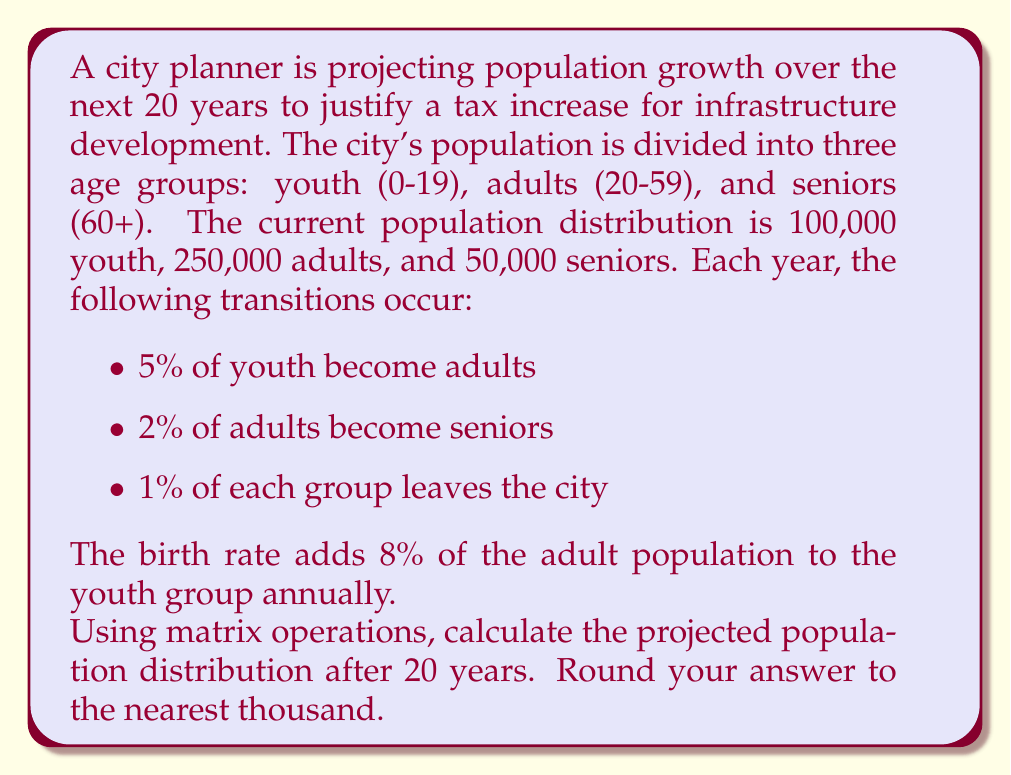Can you solve this math problem? Let's approach this step-by-step using matrix operations:

1) First, we'll set up our initial population vector:

   $$\vec{p}_0 = \begin{bmatrix} 100000 \\ 250000 \\ 50000 \end{bmatrix}$$

2) Next, we'll create our transition matrix. The columns represent youth, adults, and seniors respectively:

   $$A = \begin{bmatrix} 
   0.99 & 0.08 & 0 \\
   0.05 & 0.97 & 0 \\
   0 & 0.02 & 0.99
   \end{bmatrix}$$

3) To find the population after 20 years, we need to multiply this matrix by itself 20 times and then multiply by the initial population vector:

   $$\vec{p}_{20} = A^{20} \cdot \vec{p}_0$$

4) Let's calculate $A^{20}$ using a computer algebra system:

   $$A^{20} \approx \begin{bmatrix} 
   0.7481 & 0.1413 & 0.0031 \\
   0.1913 & 0.7255 & 0.0158 \\
   0.0606 & 0.1332 & 0.9811
   \end{bmatrix}$$

5) Now, let's multiply this by our initial population vector:

   $$\vec{p}_{20} = \begin{bmatrix} 
   0.7481 & 0.1413 & 0.0031 \\
   0.1913 & 0.7255 & 0.0158 \\
   0.0606 & 0.1332 & 0.9811
   \end{bmatrix} \cdot \begin{bmatrix} 100000 \\ 250000 \\ 50000 \end{bmatrix}$$

6) Performing this multiplication:

   $$\vec{p}_{20} \approx \begin{bmatrix} 112182 \\ 222680 \\ 82138 \end{bmatrix}$$

7) Rounding to the nearest thousand:

   $$\vec{p}_{20} \approx \begin{bmatrix} 112000 \\ 223000 \\ 82000 \end{bmatrix}$$
Answer: [112000, 223000, 82000] 